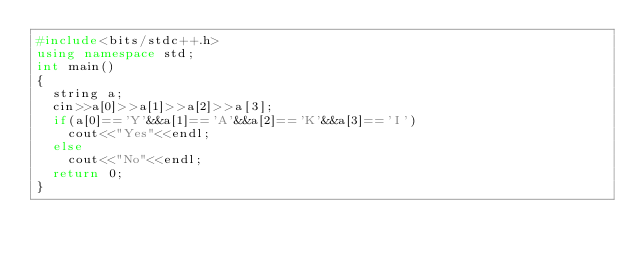Convert code to text. <code><loc_0><loc_0><loc_500><loc_500><_C++_>#include<bits/stdc++.h>
using namespace std;
int main()
{
	string a;
	cin>>a[0]>>a[1]>>a[2]>>a[3];
	if(a[0]=='Y'&&a[1]=='A'&&a[2]=='K'&&a[3]=='I')
		cout<<"Yes"<<endl;
	else
		cout<<"No"<<endl;
	return 0;
}</code> 